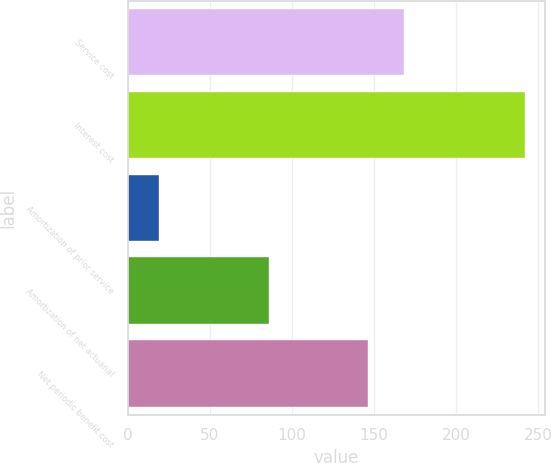Convert chart to OTSL. <chart><loc_0><loc_0><loc_500><loc_500><bar_chart><fcel>Service cost<fcel>Interest cost<fcel>Amortization of prior service<fcel>Amortization of net actuarial<fcel>Net periodic benefit cost<nl><fcel>168.3<fcel>242<fcel>19<fcel>86<fcel>146<nl></chart> 